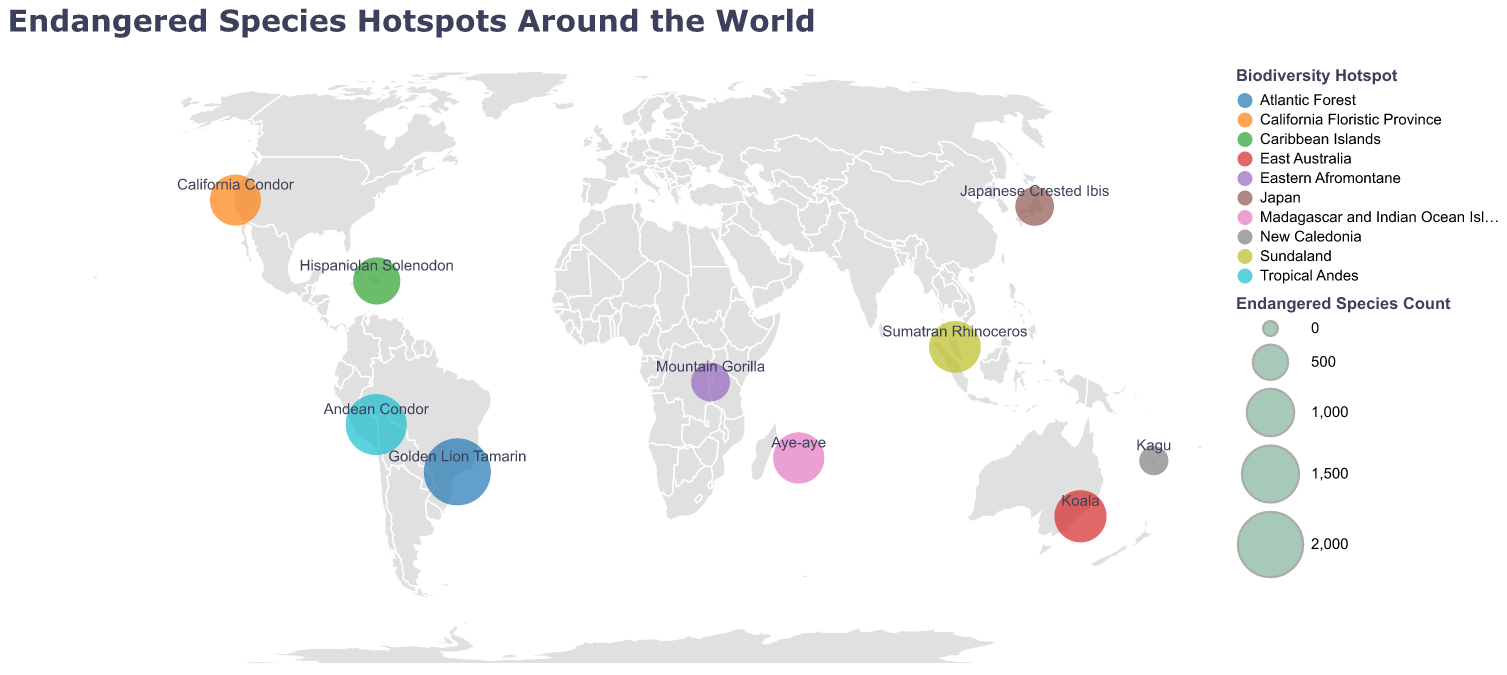Which region has the highest count of endangered species? The figure shows various regions with circles sized according to the number of endangered species. The Atlantic Forest has the largest circle, indicating it has the highest count of endangered species.
Answer: Atlantic Forest What is the notable species associated with the Eastern Afromontane region? By looking at the label near the circle representing the Eastern Afromontane region, we can see that it is the "Mountain Gorilla".
Answer: Mountain Gorilla Which regions have more than 1000 endangered species? By examining the sizes of the circles and their labels, we see that Madagascar and Indian Ocean Islands, Tropical Andes, Caribbean Islands, Sundaland, and East Australia all have circles with sizes indicating more than 1000 endangered species.
Answer: Madagascar and Indian Ocean Islands, Tropical Andes, Caribbean Islands, Sundaland, East Australia How many endangered species are in Japan compared to New Caledonia? The figure shows that Japan has 634 endangered species while New Caledonia has 314. By subtracting the count for New Caledonia from Japan, we get 634 - 314 = 320.
Answer: 320 What is the average number of endangered species in the given regions? Add the endangered species count for all regions: 636 + 1194 + 1740 + 992 + 2118 + 634 + 1216 + 314 + 1239 + 1179 = 11262. Then divide by the number of regions: 11262 / 10 = 1126.2
Answer: 1126.2 Which notable species is found in the Tropical Andes? The label near the circle for the Tropical Andes region indicates the notable species is the "Andean Condor".
Answer: Andean Condor Is the endangered species count in California Floristic Province greater than in Sundaland? By comparing the sizes of the circles and their labels, we see that California Floristic Province has 1179 endangered species, while Sundaland has 1216. 1179 is less than 1216.
Answer: No How many species are endangered in the region with the lowest count? Looking at the smallest circle and its label, New Caledonia has the lowest count of 314 endangered species.
Answer: 314 Which region in the southern hemisphere has the highest count of endangered species? By examining regions in the southern hemisphere (latitude less than 0) and comparing their circle sizes and labels, the Atlantic Forest has 2118 endangered species, the highest in the southern hemisphere.
Answer: Atlantic Forest What is the difference in endangered species counts between East Australia and Caribbean Islands? East Australia has 1239 endangered species and Caribbean Islands have 992. Subtracting the counts gives 1239 - 992 = 247.
Answer: 247 